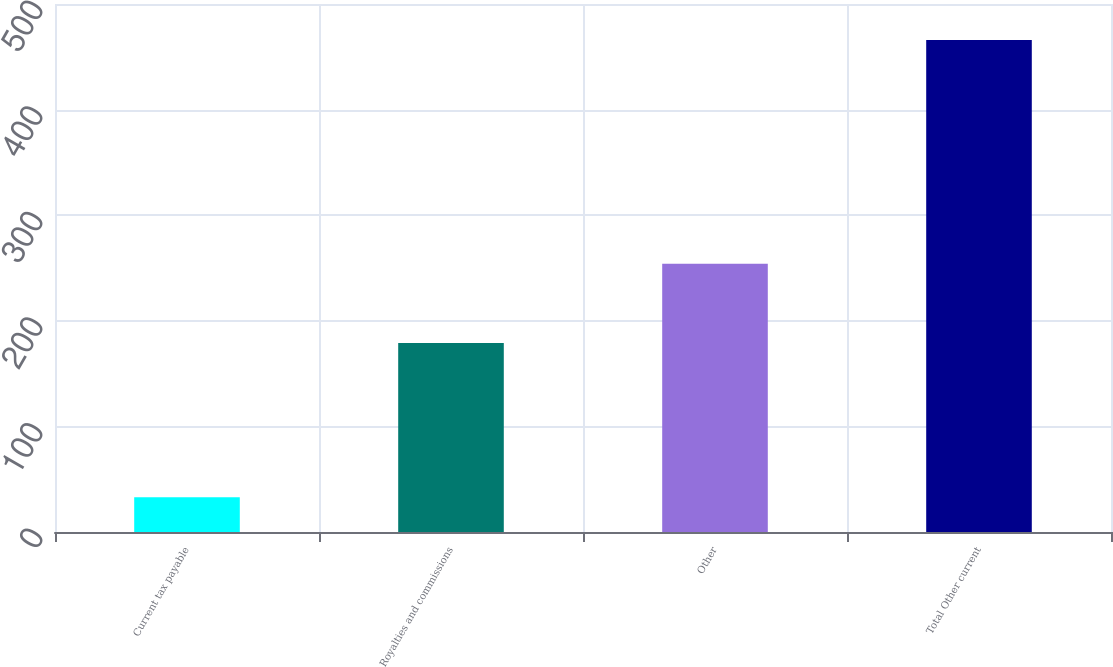Convert chart to OTSL. <chart><loc_0><loc_0><loc_500><loc_500><bar_chart><fcel>Current tax payable<fcel>Royalties and commissions<fcel>Other<fcel>Total Other current<nl><fcel>33<fcel>179<fcel>254<fcel>466<nl></chart> 